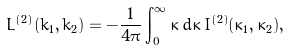Convert formula to latex. <formula><loc_0><loc_0><loc_500><loc_500>L ^ { ( 2 ) } ( k _ { 1 } , k _ { 2 } ) = - \frac { 1 } { 4 \pi } \int _ { 0 } ^ { \infty } \bar { \kappa } \, d \bar { \kappa } \, I ^ { ( 2 ) } ( \kappa _ { 1 } , \kappa _ { 2 } ) ,</formula> 